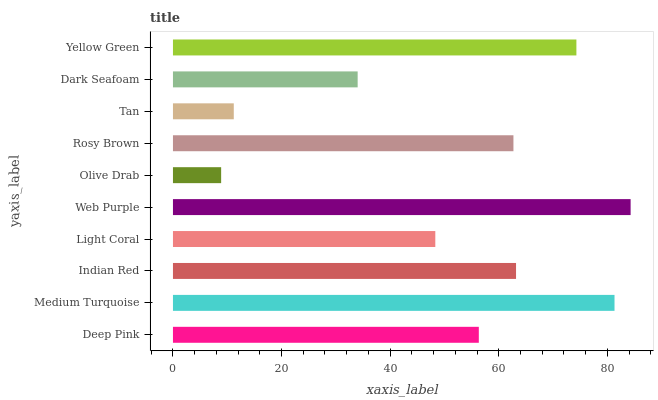Is Olive Drab the minimum?
Answer yes or no. Yes. Is Web Purple the maximum?
Answer yes or no. Yes. Is Medium Turquoise the minimum?
Answer yes or no. No. Is Medium Turquoise the maximum?
Answer yes or no. No. Is Medium Turquoise greater than Deep Pink?
Answer yes or no. Yes. Is Deep Pink less than Medium Turquoise?
Answer yes or no. Yes. Is Deep Pink greater than Medium Turquoise?
Answer yes or no. No. Is Medium Turquoise less than Deep Pink?
Answer yes or no. No. Is Rosy Brown the high median?
Answer yes or no. Yes. Is Deep Pink the low median?
Answer yes or no. Yes. Is Tan the high median?
Answer yes or no. No. Is Olive Drab the low median?
Answer yes or no. No. 